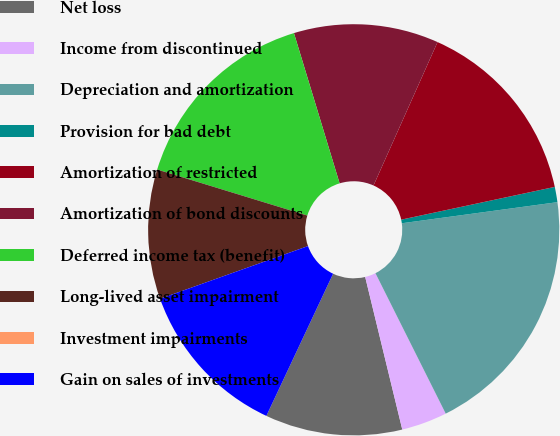<chart> <loc_0><loc_0><loc_500><loc_500><pie_chart><fcel>Net loss<fcel>Income from discontinued<fcel>Depreciation and amortization<fcel>Provision for bad debt<fcel>Amortization of restricted<fcel>Amortization of bond discounts<fcel>Deferred income tax (benefit)<fcel>Long-lived asset impairment<fcel>Investment impairments<fcel>Gain on sales of investments<nl><fcel>10.78%<fcel>3.59%<fcel>19.76%<fcel>1.2%<fcel>14.97%<fcel>11.38%<fcel>15.57%<fcel>10.18%<fcel>0.0%<fcel>12.57%<nl></chart> 